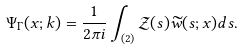Convert formula to latex. <formula><loc_0><loc_0><loc_500><loc_500>\Psi _ { \Gamma } ( x ; k ) = \frac { 1 } { 2 \pi i } \int _ { ( 2 ) } \mathcal { Z } ( s ) \widetilde { w } ( s ; x ) d s .</formula> 